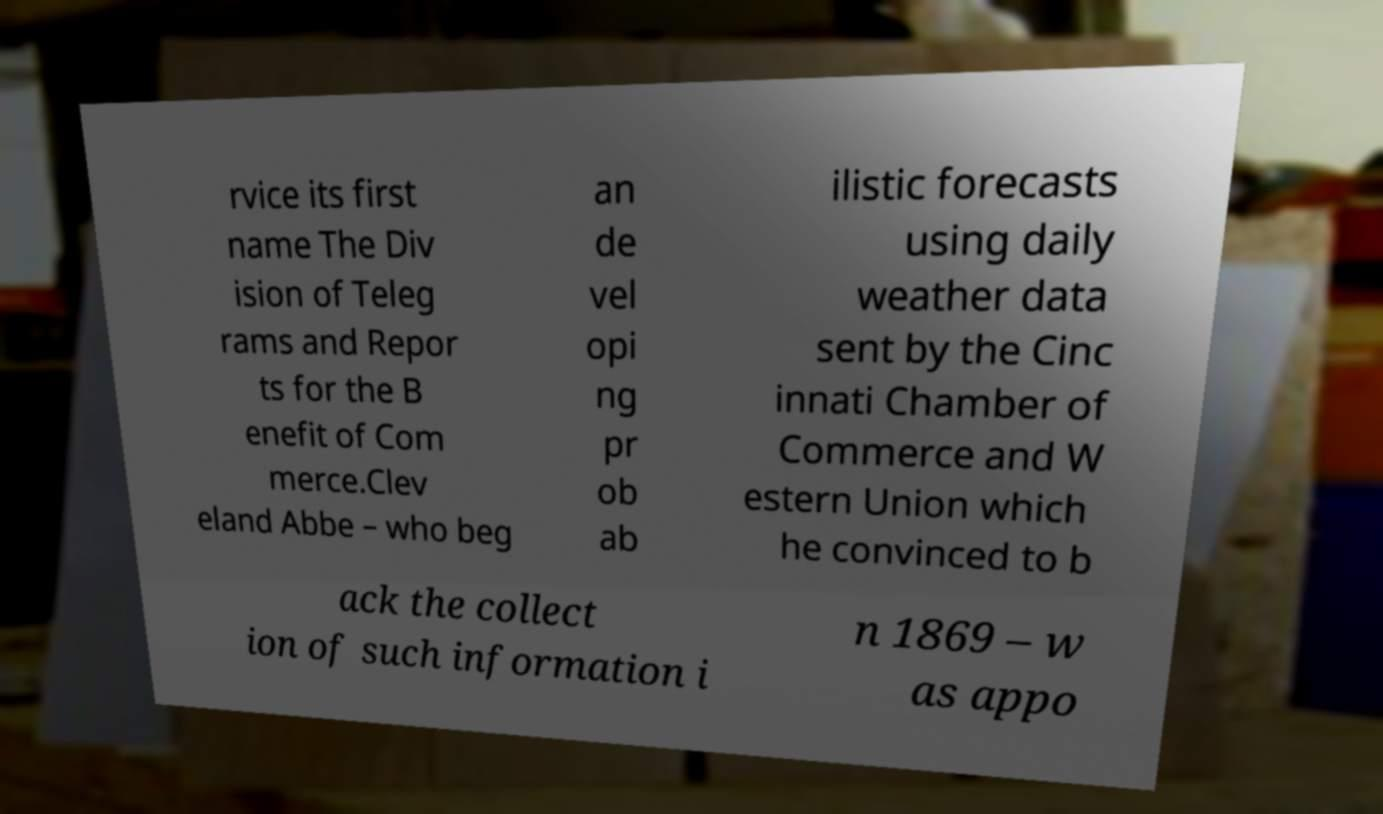There's text embedded in this image that I need extracted. Can you transcribe it verbatim? rvice its first name The Div ision of Teleg rams and Repor ts for the B enefit of Com merce.Clev eland Abbe – who beg an de vel opi ng pr ob ab ilistic forecasts using daily weather data sent by the Cinc innati Chamber of Commerce and W estern Union which he convinced to b ack the collect ion of such information i n 1869 – w as appo 